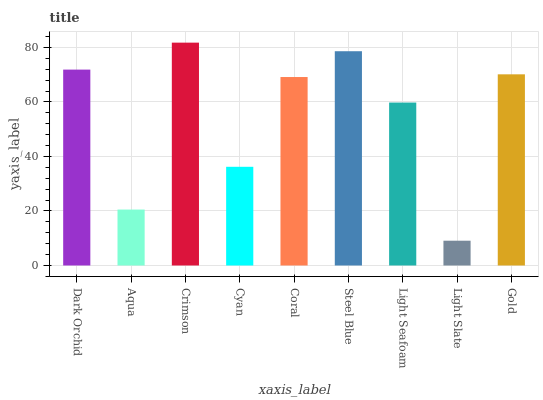Is Light Slate the minimum?
Answer yes or no. Yes. Is Crimson the maximum?
Answer yes or no. Yes. Is Aqua the minimum?
Answer yes or no. No. Is Aqua the maximum?
Answer yes or no. No. Is Dark Orchid greater than Aqua?
Answer yes or no. Yes. Is Aqua less than Dark Orchid?
Answer yes or no. Yes. Is Aqua greater than Dark Orchid?
Answer yes or no. No. Is Dark Orchid less than Aqua?
Answer yes or no. No. Is Coral the high median?
Answer yes or no. Yes. Is Coral the low median?
Answer yes or no. Yes. Is Aqua the high median?
Answer yes or no. No. Is Light Slate the low median?
Answer yes or no. No. 